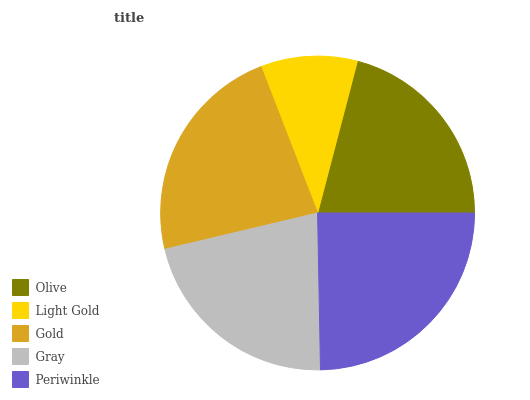Is Light Gold the minimum?
Answer yes or no. Yes. Is Periwinkle the maximum?
Answer yes or no. Yes. Is Gold the minimum?
Answer yes or no. No. Is Gold the maximum?
Answer yes or no. No. Is Gold greater than Light Gold?
Answer yes or no. Yes. Is Light Gold less than Gold?
Answer yes or no. Yes. Is Light Gold greater than Gold?
Answer yes or no. No. Is Gold less than Light Gold?
Answer yes or no. No. Is Gray the high median?
Answer yes or no. Yes. Is Gray the low median?
Answer yes or no. Yes. Is Periwinkle the high median?
Answer yes or no. No. Is Olive the low median?
Answer yes or no. No. 